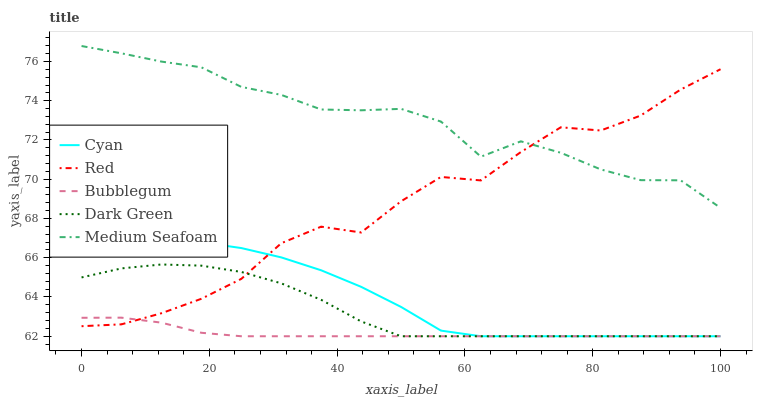Does Bubblegum have the minimum area under the curve?
Answer yes or no. Yes. Does Medium Seafoam have the maximum area under the curve?
Answer yes or no. Yes. Does Medium Seafoam have the minimum area under the curve?
Answer yes or no. No. Does Bubblegum have the maximum area under the curve?
Answer yes or no. No. Is Bubblegum the smoothest?
Answer yes or no. Yes. Is Red the roughest?
Answer yes or no. Yes. Is Medium Seafoam the smoothest?
Answer yes or no. No. Is Medium Seafoam the roughest?
Answer yes or no. No. Does Cyan have the lowest value?
Answer yes or no. Yes. Does Medium Seafoam have the lowest value?
Answer yes or no. No. Does Medium Seafoam have the highest value?
Answer yes or no. Yes. Does Bubblegum have the highest value?
Answer yes or no. No. Is Cyan less than Medium Seafoam?
Answer yes or no. Yes. Is Medium Seafoam greater than Cyan?
Answer yes or no. Yes. Does Bubblegum intersect Dark Green?
Answer yes or no. Yes. Is Bubblegum less than Dark Green?
Answer yes or no. No. Is Bubblegum greater than Dark Green?
Answer yes or no. No. Does Cyan intersect Medium Seafoam?
Answer yes or no. No. 